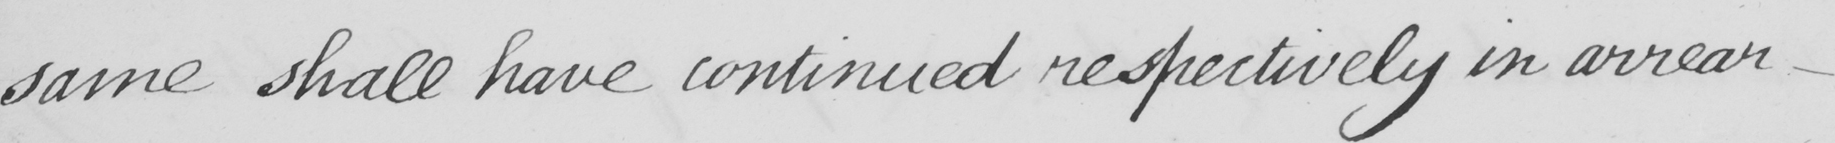Can you tell me what this handwritten text says? same shall have continued respectively in arrear  _ 